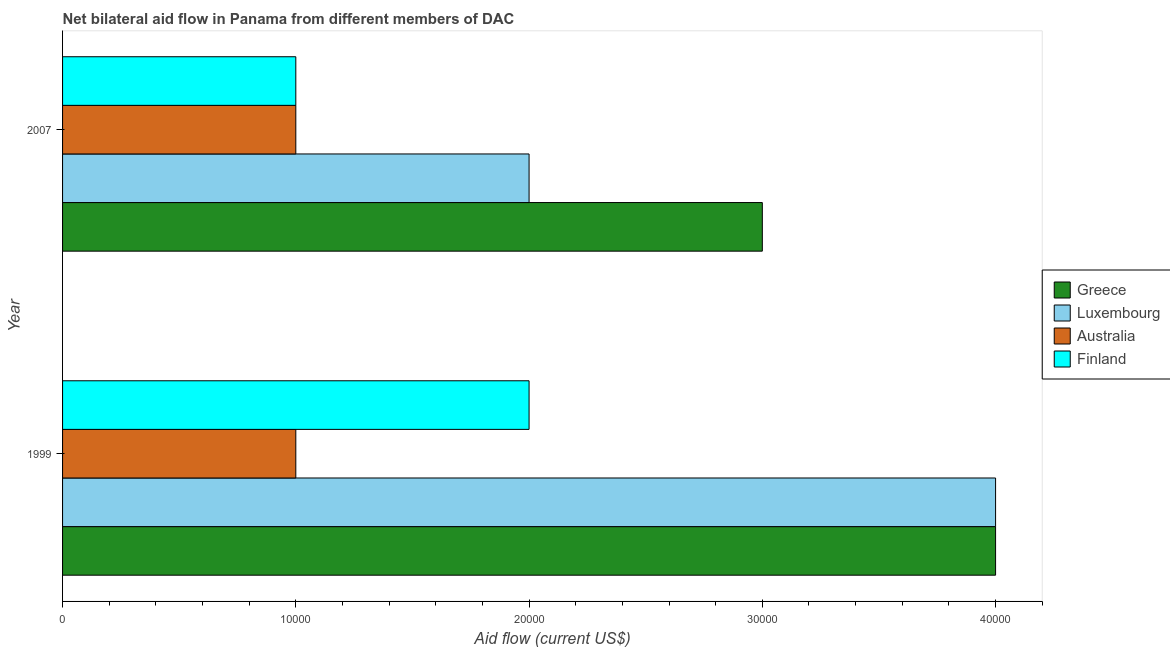How many different coloured bars are there?
Ensure brevity in your answer.  4. How many groups of bars are there?
Keep it short and to the point. 2. Are the number of bars per tick equal to the number of legend labels?
Give a very brief answer. Yes. How many bars are there on the 2nd tick from the top?
Offer a very short reply. 4. How many bars are there on the 1st tick from the bottom?
Keep it short and to the point. 4. What is the label of the 2nd group of bars from the top?
Offer a very short reply. 1999. What is the amount of aid given by australia in 1999?
Your answer should be very brief. 10000. Across all years, what is the maximum amount of aid given by finland?
Your answer should be compact. 2.00e+04. Across all years, what is the minimum amount of aid given by greece?
Ensure brevity in your answer.  3.00e+04. What is the total amount of aid given by australia in the graph?
Ensure brevity in your answer.  2.00e+04. What is the difference between the amount of aid given by greece in 1999 and that in 2007?
Your answer should be compact. 10000. What is the difference between the amount of aid given by australia in 1999 and the amount of aid given by greece in 2007?
Your response must be concise. -2.00e+04. What is the average amount of aid given by luxembourg per year?
Ensure brevity in your answer.  3.00e+04. In the year 2007, what is the difference between the amount of aid given by australia and amount of aid given by finland?
Your answer should be compact. 0. In how many years, is the amount of aid given by luxembourg greater than 40000 US$?
Keep it short and to the point. 0. What is the ratio of the amount of aid given by australia in 1999 to that in 2007?
Your answer should be compact. 1. In how many years, is the amount of aid given by luxembourg greater than the average amount of aid given by luxembourg taken over all years?
Give a very brief answer. 1. What does the 3rd bar from the bottom in 2007 represents?
Offer a terse response. Australia. What is the difference between two consecutive major ticks on the X-axis?
Your answer should be very brief. 10000. Does the graph contain any zero values?
Offer a very short reply. No. Does the graph contain grids?
Provide a succinct answer. No. How are the legend labels stacked?
Give a very brief answer. Vertical. What is the title of the graph?
Provide a short and direct response. Net bilateral aid flow in Panama from different members of DAC. Does "Italy" appear as one of the legend labels in the graph?
Ensure brevity in your answer.  No. What is the label or title of the Y-axis?
Make the answer very short. Year. What is the Aid flow (current US$) in Luxembourg in 1999?
Keep it short and to the point. 4.00e+04. What is the Aid flow (current US$) in Finland in 1999?
Your answer should be very brief. 2.00e+04. What is the Aid flow (current US$) of Greece in 2007?
Provide a succinct answer. 3.00e+04. What is the Aid flow (current US$) in Australia in 2007?
Provide a succinct answer. 10000. What is the Aid flow (current US$) in Finland in 2007?
Give a very brief answer. 10000. Across all years, what is the maximum Aid flow (current US$) of Greece?
Provide a short and direct response. 4.00e+04. Across all years, what is the maximum Aid flow (current US$) of Australia?
Provide a succinct answer. 10000. Across all years, what is the maximum Aid flow (current US$) in Finland?
Provide a succinct answer. 2.00e+04. Across all years, what is the minimum Aid flow (current US$) in Greece?
Your response must be concise. 3.00e+04. Across all years, what is the minimum Aid flow (current US$) in Luxembourg?
Offer a terse response. 2.00e+04. What is the total Aid flow (current US$) in Greece in the graph?
Your answer should be compact. 7.00e+04. What is the difference between the Aid flow (current US$) in Australia in 1999 and that in 2007?
Your answer should be very brief. 0. What is the difference between the Aid flow (current US$) of Finland in 1999 and that in 2007?
Your response must be concise. 10000. What is the difference between the Aid flow (current US$) in Greece in 1999 and the Aid flow (current US$) in Luxembourg in 2007?
Your response must be concise. 2.00e+04. What is the difference between the Aid flow (current US$) in Greece in 1999 and the Aid flow (current US$) in Australia in 2007?
Provide a succinct answer. 3.00e+04. What is the average Aid flow (current US$) of Greece per year?
Offer a terse response. 3.50e+04. What is the average Aid flow (current US$) in Finland per year?
Your response must be concise. 1.50e+04. In the year 1999, what is the difference between the Aid flow (current US$) in Greece and Aid flow (current US$) in Australia?
Offer a very short reply. 3.00e+04. In the year 1999, what is the difference between the Aid flow (current US$) of Greece and Aid flow (current US$) of Finland?
Provide a succinct answer. 2.00e+04. In the year 1999, what is the difference between the Aid flow (current US$) in Australia and Aid flow (current US$) in Finland?
Your response must be concise. -10000. In the year 2007, what is the difference between the Aid flow (current US$) of Greece and Aid flow (current US$) of Luxembourg?
Make the answer very short. 10000. In the year 2007, what is the difference between the Aid flow (current US$) in Greece and Aid flow (current US$) in Australia?
Provide a succinct answer. 2.00e+04. In the year 2007, what is the difference between the Aid flow (current US$) of Greece and Aid flow (current US$) of Finland?
Keep it short and to the point. 2.00e+04. In the year 2007, what is the difference between the Aid flow (current US$) in Luxembourg and Aid flow (current US$) in Finland?
Your answer should be compact. 10000. What is the ratio of the Aid flow (current US$) in Greece in 1999 to that in 2007?
Your answer should be compact. 1.33. What is the ratio of the Aid flow (current US$) of Australia in 1999 to that in 2007?
Ensure brevity in your answer.  1. What is the difference between the highest and the second highest Aid flow (current US$) in Finland?
Make the answer very short. 10000. What is the difference between the highest and the lowest Aid flow (current US$) of Australia?
Offer a very short reply. 0. 